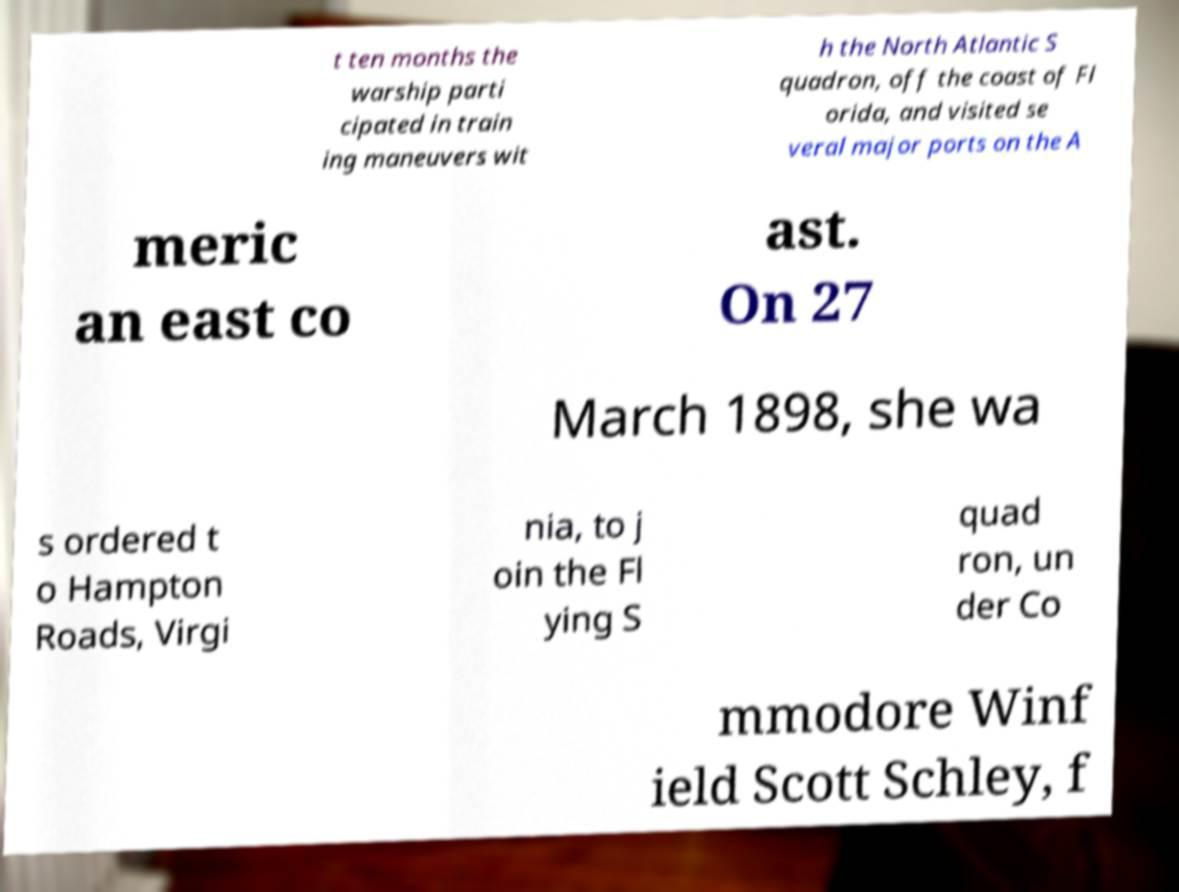Can you read and provide the text displayed in the image?This photo seems to have some interesting text. Can you extract and type it out for me? t ten months the warship parti cipated in train ing maneuvers wit h the North Atlantic S quadron, off the coast of Fl orida, and visited se veral major ports on the A meric an east co ast. On 27 March 1898, she wa s ordered t o Hampton Roads, Virgi nia, to j oin the Fl ying S quad ron, un der Co mmodore Winf ield Scott Schley, f 